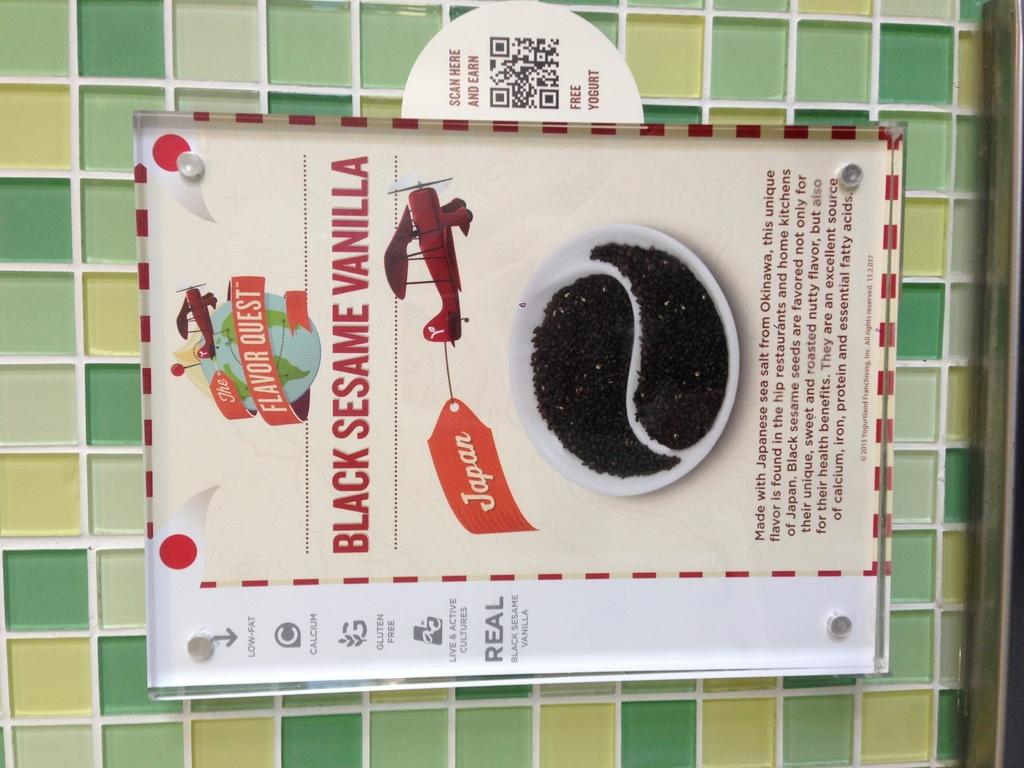<image>
Write a terse but informative summary of the picture. The flavour quest of the Black Sesame Vanilla seasoning. 